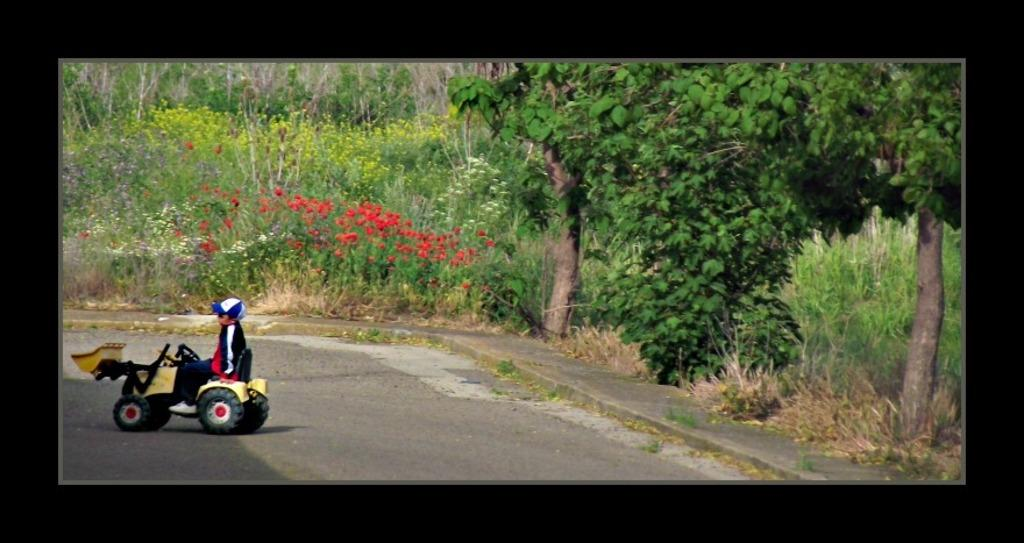What is the main subject in the center of the image? There is a toy vehicle in the center of the image. Who is interacting with the toy vehicle? A kid is sitting in the vehicle. What can be seen in the background of the image? There are flowers, trees, and grass in the background of the image. Can you see any marbles rolling on the grass in the image? There are no marbles present in the image, and therefore no such activity can be observed. 